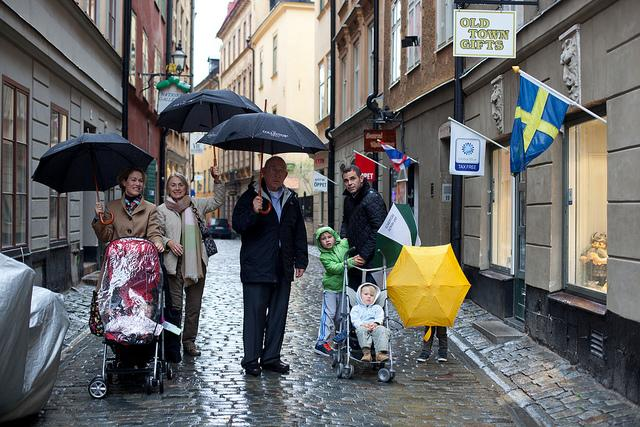What kind of flag is the blue and yellow one?

Choices:
A) swedens flag
B) scotlands flag
C) germanys flag
D) denmarks flag swedens flag 